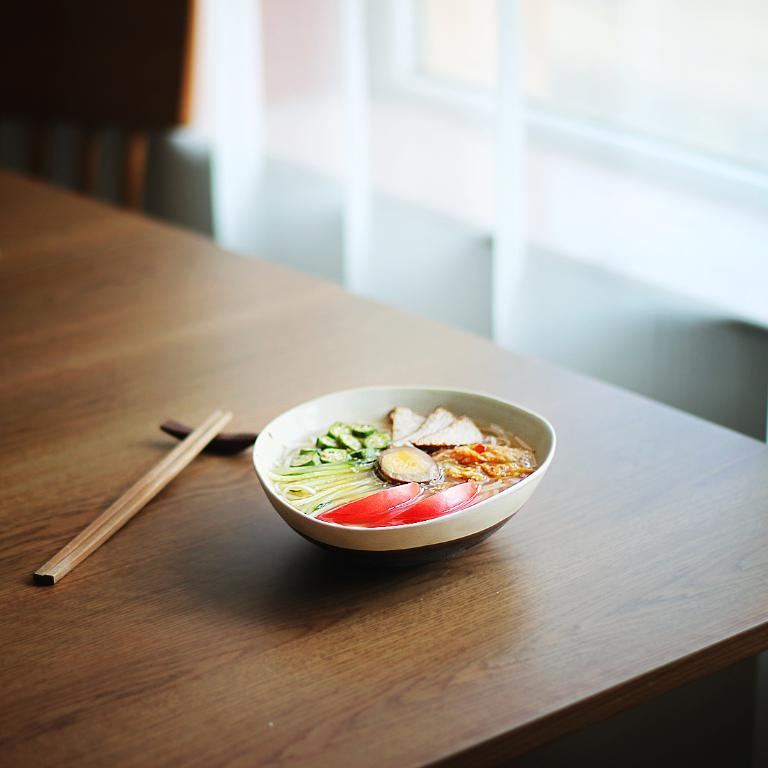What is the main piece of furniture in the picture? There is a table in the picture. What is placed on the table? Food items are placed in a bowl on the table. What utensil is beside the bowl? Chopsticks are beside the bowl. Can you describe any other furniture in the picture? There is a chair in the background of the picture. How many balloons are floating above the table in the image? There are no balloons present in the image. What type of fire can be seen in the background of the image? There is no fire visible in the image. 